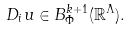<formula> <loc_0><loc_0><loc_500><loc_500>D _ { i } u \in B _ { \Phi } ^ { k + 1 } ( \mathbb { R } ^ { \Lambda } ) .</formula> 